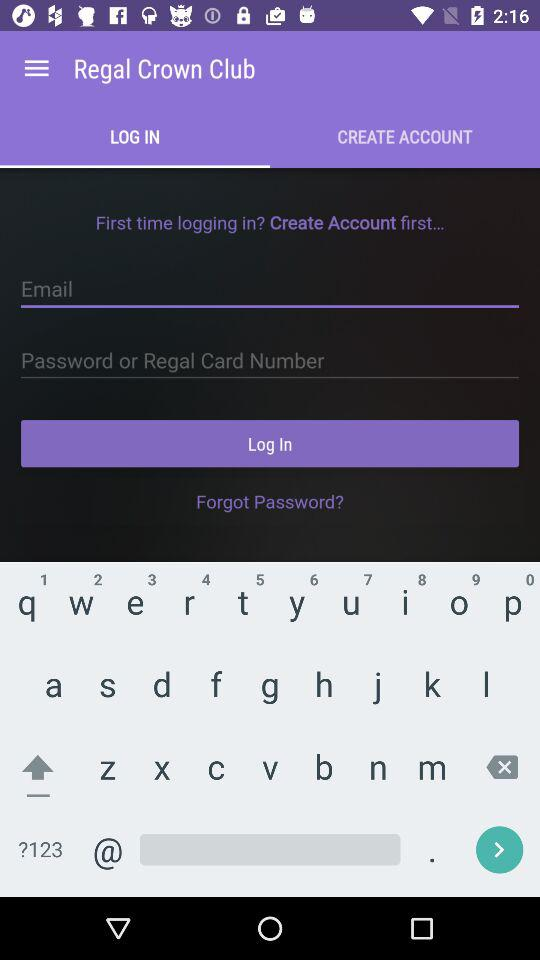Which tab has been selected? The tab that has been selected is "LOG IN". 